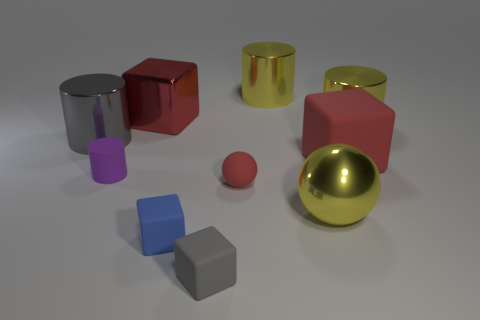Are there any other things that are the same color as the large metallic ball?
Make the answer very short. Yes. What number of things are behind the large metal block and on the left side of the tiny purple rubber cylinder?
Your answer should be very brief. 0. There is a block behind the big rubber cube; does it have the same size as the matte thing in front of the tiny blue rubber thing?
Ensure brevity in your answer.  No. How many objects are small things that are behind the large sphere or red things?
Keep it short and to the point. 4. What material is the yellow cylinder that is left of the red matte cube?
Provide a succinct answer. Metal. What is the purple thing made of?
Make the answer very short. Rubber. What is the material of the cube on the right side of the large metal sphere that is to the left of the large block on the right side of the small rubber sphere?
Make the answer very short. Rubber. Is there any other thing that is the same material as the small blue block?
Give a very brief answer. Yes. There is a blue block; is it the same size as the yellow thing that is in front of the gray metallic cylinder?
Provide a succinct answer. No. What number of things are either big cubes right of the small rubber sphere or metallic cylinders that are to the left of the big matte thing?
Your answer should be very brief. 3. 